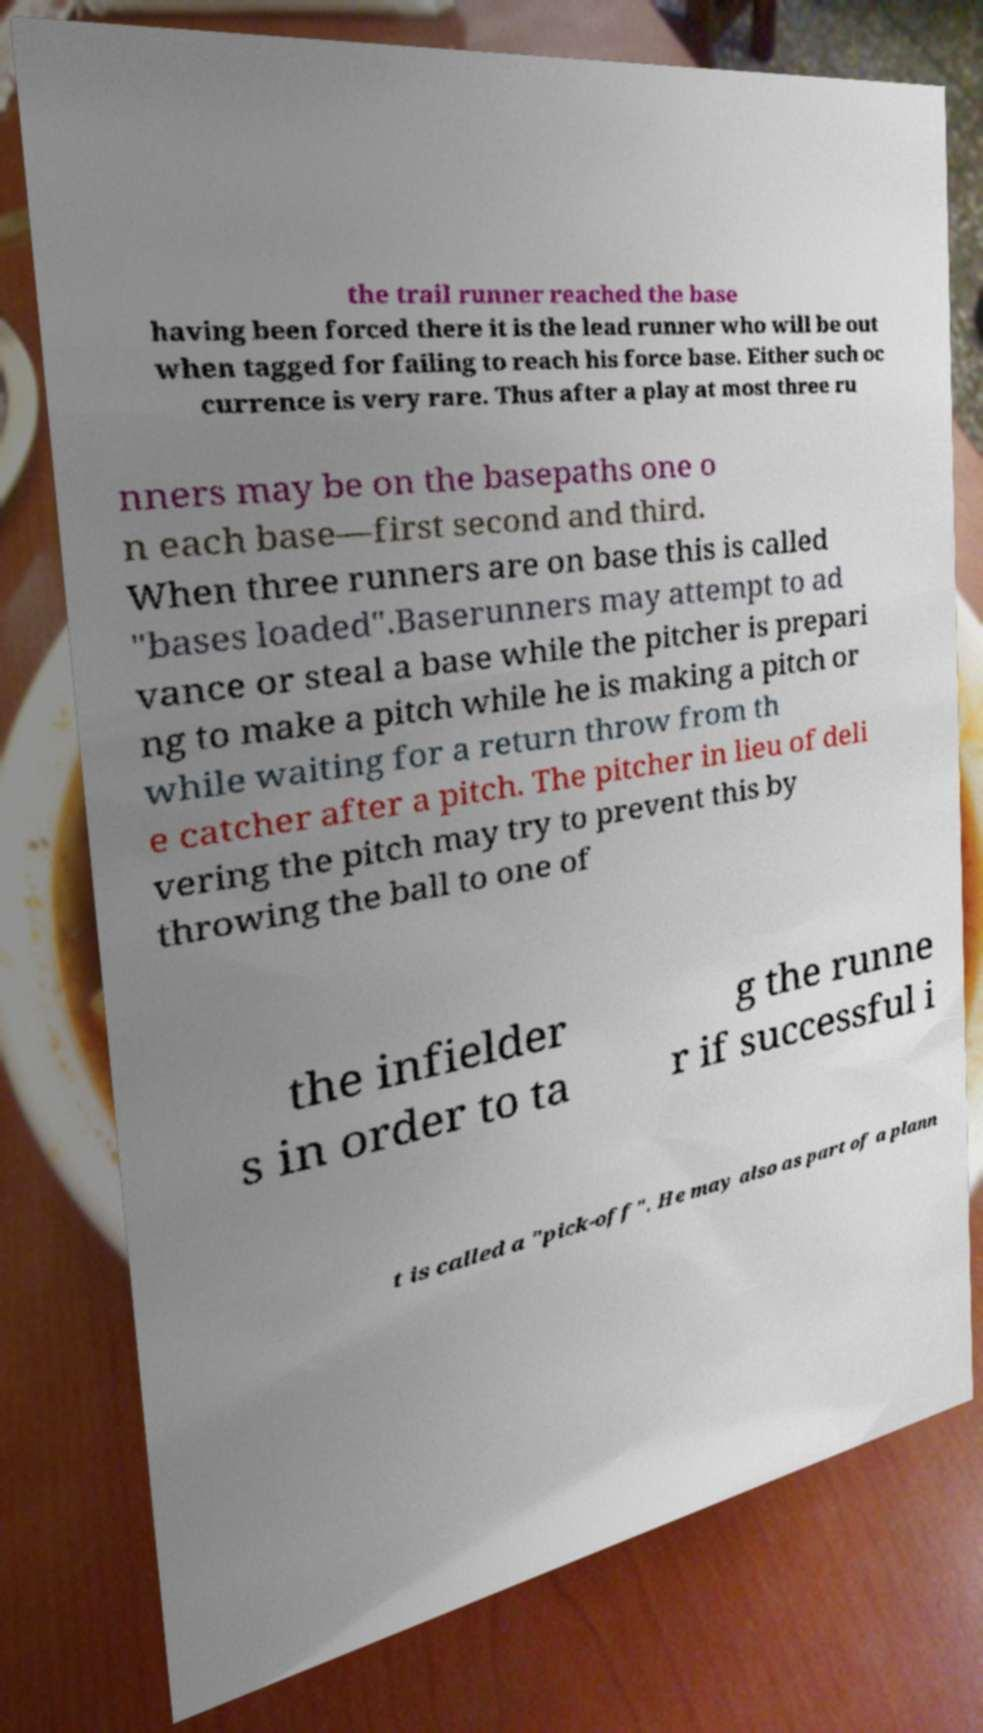What messages or text are displayed in this image? I need them in a readable, typed format. the trail runner reached the base having been forced there it is the lead runner who will be out when tagged for failing to reach his force base. Either such oc currence is very rare. Thus after a play at most three ru nners may be on the basepaths one o n each base—first second and third. When three runners are on base this is called "bases loaded".Baserunners may attempt to ad vance or steal a base while the pitcher is prepari ng to make a pitch while he is making a pitch or while waiting for a return throw from th e catcher after a pitch. The pitcher in lieu of deli vering the pitch may try to prevent this by throwing the ball to one of the infielder s in order to ta g the runne r if successful i t is called a "pick-off". He may also as part of a plann 